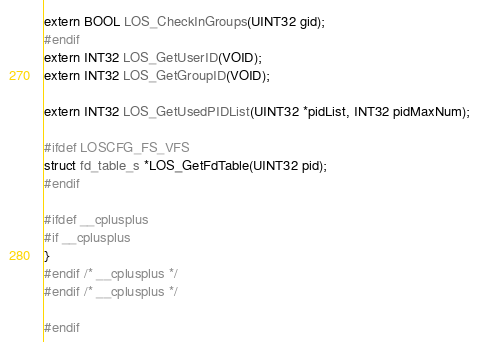<code> <loc_0><loc_0><loc_500><loc_500><_C_>extern BOOL LOS_CheckInGroups(UINT32 gid);
#endif
extern INT32 LOS_GetUserID(VOID);
extern INT32 LOS_GetGroupID(VOID);

extern INT32 LOS_GetUsedPIDList(UINT32 *pidList, INT32 pidMaxNum);

#ifdef LOSCFG_FS_VFS
struct fd_table_s *LOS_GetFdTable(UINT32 pid);
#endif

#ifdef __cplusplus
#if __cplusplus
}
#endif /* __cplusplus */
#endif /* __cplusplus */

#endif
</code> 